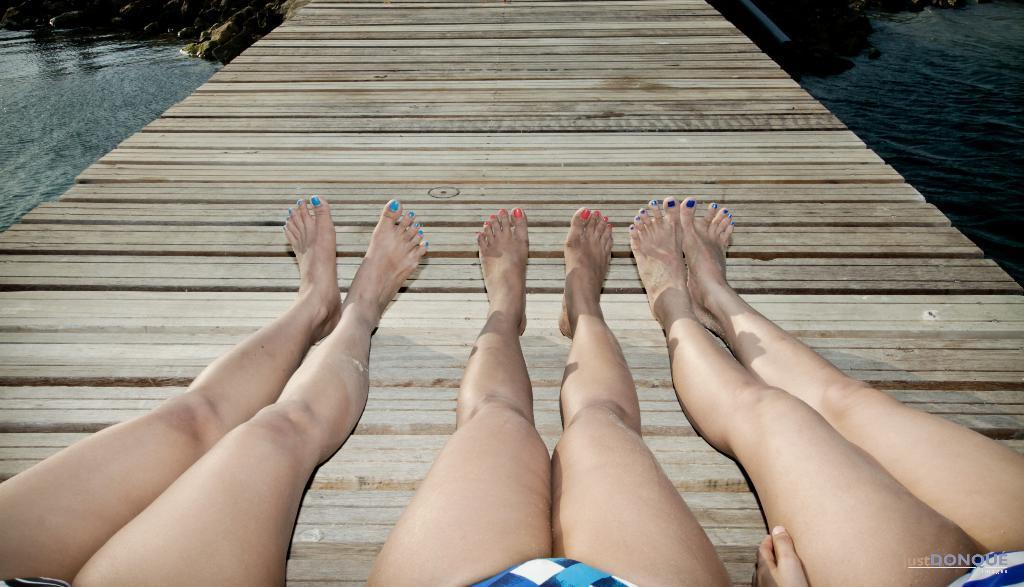How many people are in the image? There are three people in the image. What type of surface are the people standing on? The people are standing on a wooden floor. What natural elements can be seen in the image? Rocks and water are visible in the image. What type of support can be seen in the image? There is no specific support structure visible in the image. 